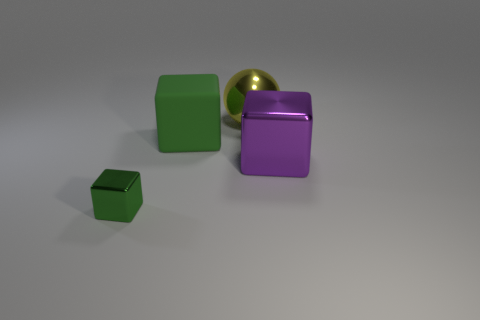Is the small metallic thing the same shape as the purple metallic object?
Provide a short and direct response. Yes. There is a cube on the right side of the large yellow ball; what is its size?
Give a very brief answer. Large. There is a purple thing that is the same material as the yellow ball; what size is it?
Make the answer very short. Large. Is the number of brown metal blocks less than the number of purple objects?
Your answer should be compact. Yes. What is the material of the other block that is the same size as the matte block?
Your answer should be compact. Metal. Is the number of purple metallic objects greater than the number of large cubes?
Provide a succinct answer. No. How many other things are the same color as the sphere?
Provide a short and direct response. 0. What number of things are to the right of the tiny green metal cube and in front of the big rubber cube?
Offer a very short reply. 1. Is there anything else that has the same size as the purple metallic cube?
Your response must be concise. Yes. Are there more spheres that are in front of the big ball than large purple things that are behind the rubber thing?
Offer a terse response. No. 